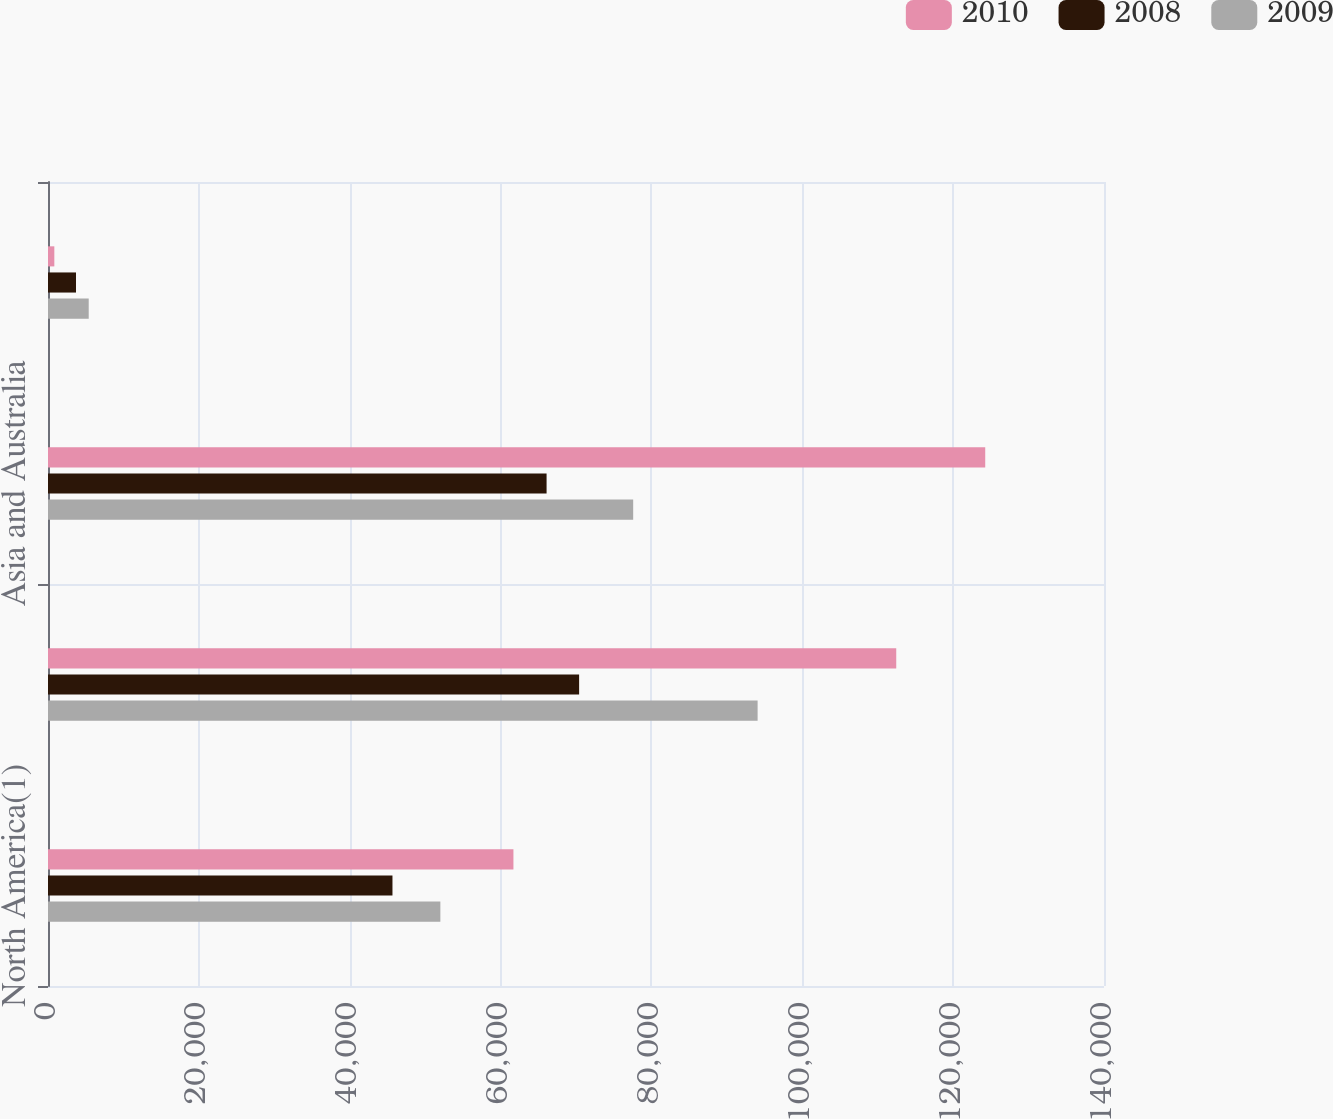Convert chart. <chart><loc_0><loc_0><loc_500><loc_500><stacked_bar_chart><ecel><fcel>North America(1)<fcel>Europe<fcel>Asia and Australia<fcel>Rest of World<nl><fcel>2010<fcel>61706<fcel>112456<fcel>124254<fcel>840<nl><fcel>2008<fcel>45668<fcel>70413<fcel>66100<fcel>3713<nl><fcel>2009<fcel>52018<fcel>94077<fcel>77582<fcel>5399<nl></chart> 